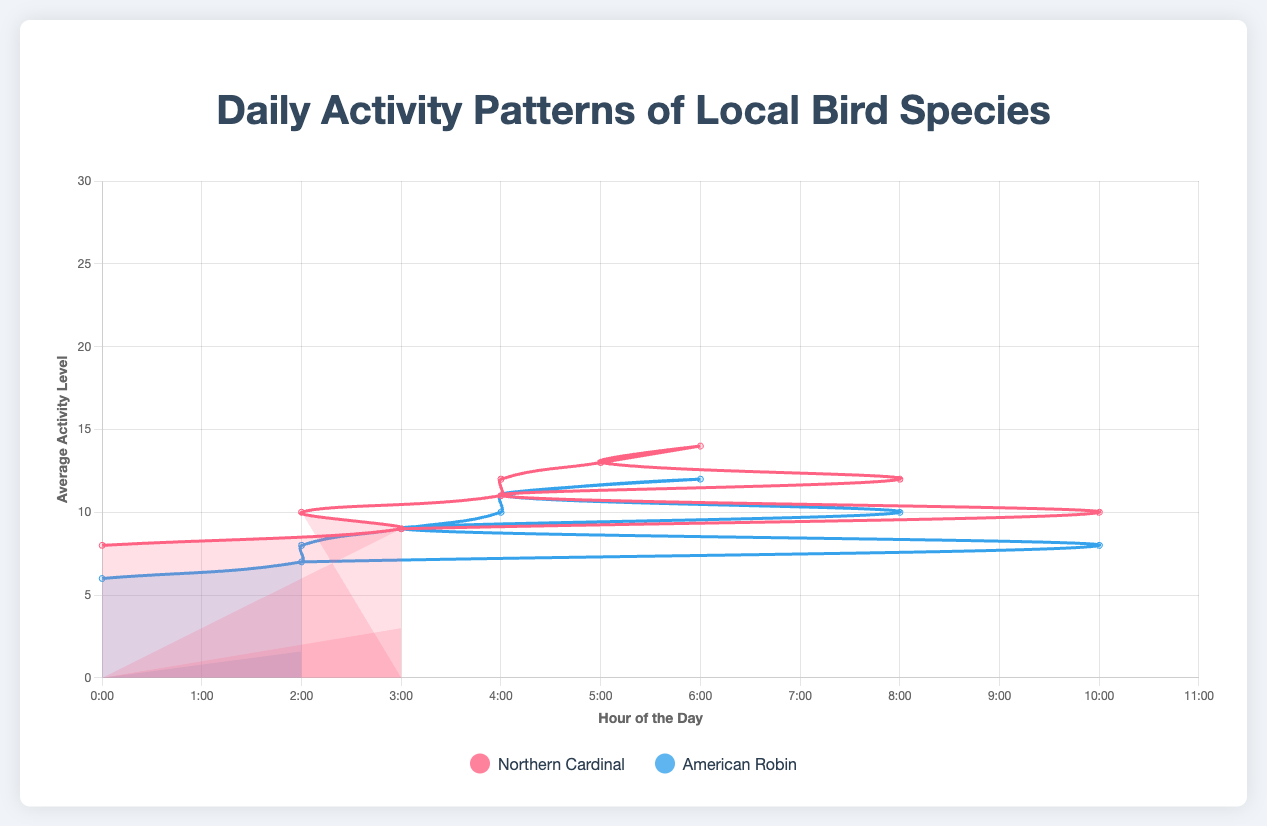What is the general trend in the activity levels of the Northern Cardinal from January to July? In January, the activity levels for the Northern Cardinal start at 5 and increase gradually each month until they reach 11 in July.
Answer: Increasing trend Which bird species shows a higher maximum activity level in March? In March, the Northern Cardinal's activity peaks at 26, while the American Robin's activity peaks at 25.
Answer: Northern Cardinal At what hour of the day does the activity level of the American Robin peak in April? In April, the activity level of the American Robin peaks at 26 at 12:00 PM (midday).
Answer: 12:00 PM How does the activity pattern of the Northern Cardinal in June compare to that of the American Robin in June? In June, the Northern Cardinal's activity starts at 10, peaks at 29 around midday, and then declines. The American Robin's activity starts at 8, peaks at 28 around midday, and similarly declines.
Answer: Comparable with slight variations What is the difference between the maximum activity levels of the Northern Cardinal in January and July? The maximum activity level of the Northern Cardinal in January is 24 and in July it is 30. The difference between them is 30 - 24 = 6.
Answer: 6 Which month shows the highest activity level for the Northern Cardinal, and what is that level? The highest activity level for the Northern Cardinal is in July, where it reaches 30.
Answer: July, 30 During which months does the American Robin show an increase in activity during the first half of the day? The American Robin's activity increases during the first half of the day from January to July and again from December, as seen from the rising patterns in the morning hours.
Answer: January to July, December In which months do the activity levels of both species follow a similar pattern? Both species show similar activity patterns in March, May, and September, where the activity levels rise in the morning, peak around midday, and decline in the afternoon.
Answer: March, May, September How does the activity of the Northern Cardinal change from April to May at 8:00 AM? At 8:00 AM, the activity level of the Northern Cardinal increases from 8 in April to 9 in May.
Answer: Increases During which hour do both the Northern Cardinal and American Robin exhibit their lowest activity levels in July? In July, both species exhibit their lowest activity levels at 10:00 PM.
Answer: 10:00 PM 